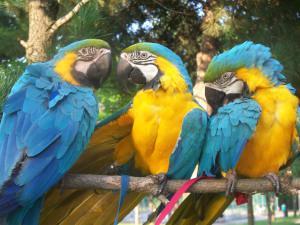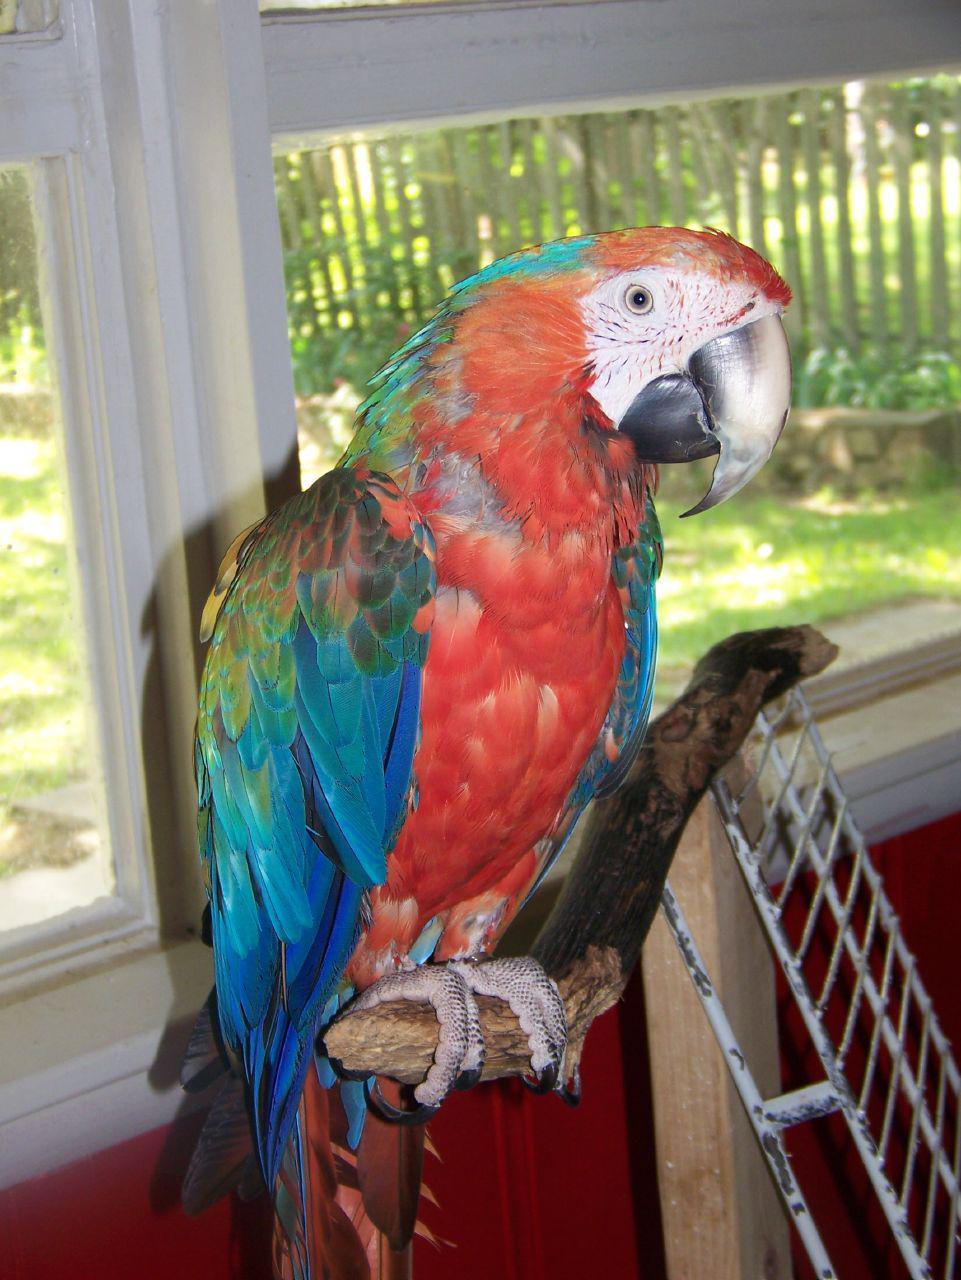The first image is the image on the left, the second image is the image on the right. Evaluate the accuracy of this statement regarding the images: "There are exactly four birds in total.". Is it true? Answer yes or no. Yes. The first image is the image on the left, the second image is the image on the right. For the images shown, is this caption "There are no less than three parrots resting on a branch." true? Answer yes or no. Yes. 